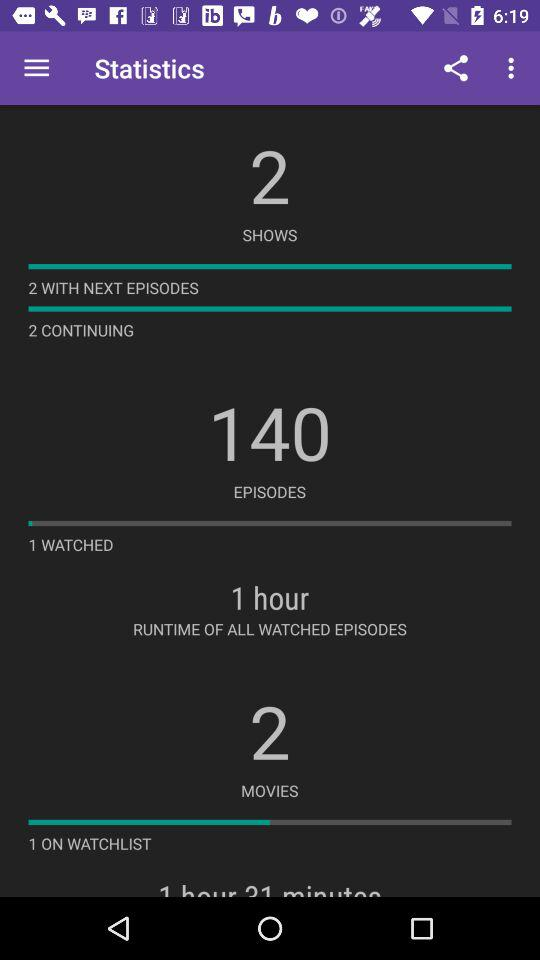What is the number of watched episodes? The number of watched episodes is 1. 